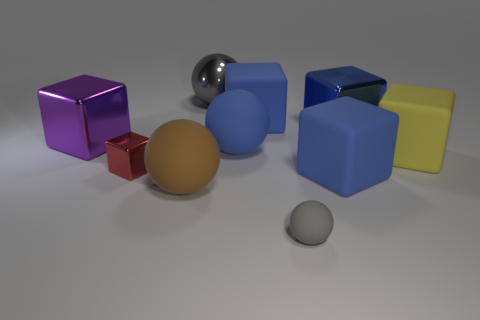Subtract all gray spheres. How many were subtracted if there are1gray spheres left? 1 Subtract all red spheres. How many blue cubes are left? 3 Subtract 2 cubes. How many cubes are left? 4 Subtract all red cubes. How many cubes are left? 5 Subtract all yellow blocks. How many blocks are left? 5 Subtract all purple cubes. Subtract all green cylinders. How many cubes are left? 5 Subtract all spheres. How many objects are left? 6 Add 5 big red rubber cylinders. How many big red rubber cylinders exist? 5 Subtract 0 brown cubes. How many objects are left? 10 Subtract all big cubes. Subtract all brown objects. How many objects are left? 4 